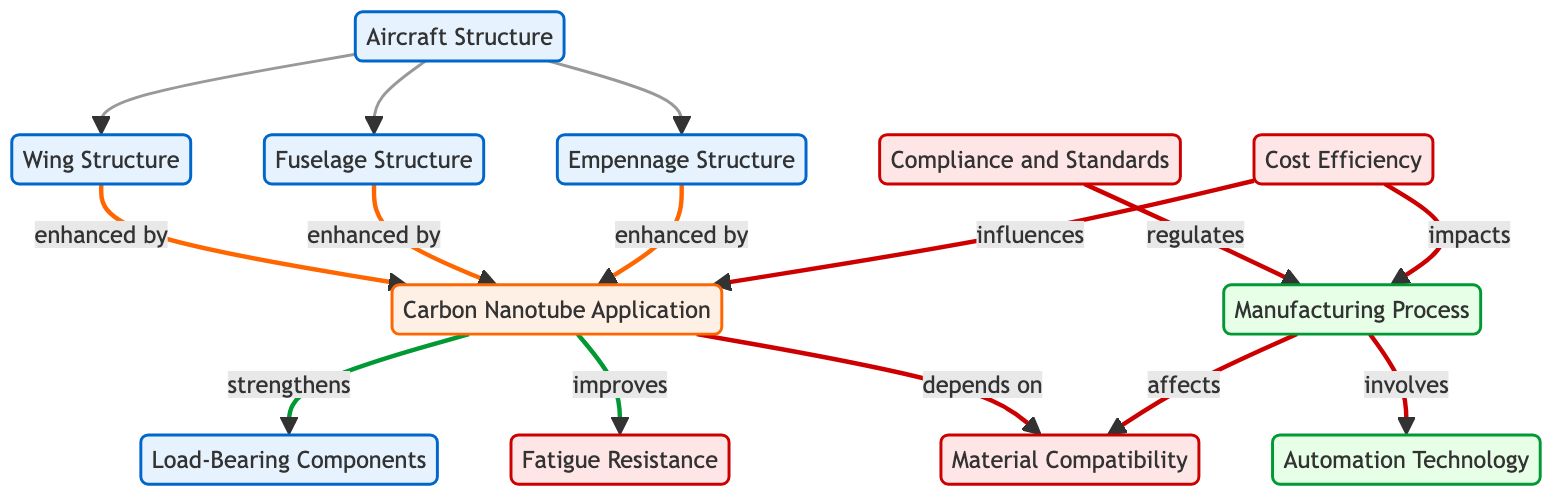What are the three main structures included in Aircraft Structure? The diagram shows that the Aircraft Structure includes Wing Structure, Fuselage Structure, and Empennage Structure, as indicated by the arrows labeled "includes."
Answer: Wing Structure, Fuselage Structure, Empennage Structure How many nodes are representing different components in this diagram? The diagram lists 12 distinct nodes, including the main structures, carbon nanotube application, and various factors or processes related to their integration.
Answer: 12 What relationship exists between the Wing Structure and Carbon Nanotube Application? The arrow labeled "enhanced by" connects the Wing Structure and Carbon Nanotube Application, indicating that the application of carbon nanotubes enhances the wing structure.
Answer: enhanced by Which factor does the Manufacturing Process affect besides Material Compatibility? While Manufacturing Process affects Material Compatibility, it is also indicated to involve Automation Technology, as there’s an arrow labeled "involves" pointing toward Automation Technology.
Answer: Automation Technology What influences the Carbon Nanotube Application? The diagram indicates that Cost Efficiency influences Carbon Nanotube Application, visible through the arrow labeled "influences."
Answer: Cost Efficiency Which components directly depend on Carbon Nanotube Application? Load-Bearing Components and Fatigue Resistance are both directly linked to Carbon Nanotube Application, with arrows indicating that it strengthens and improves these components, respectively.
Answer: Load-Bearing Components, Fatigue Resistance How does Compliance and Standards relate to Manufacturing Process? Compliance and Standards regulate the Manufacturing Process, as represented by the arrow labeled "regulates" connecting the two nodes in the diagram.
Answer: regulates What key relationship defines the impact of Cost Efficiency on Manufacturing Process? The diagram shows that Cost Efficiency impacts the Manufacturing Process, with an arrow labeled "impacts" indicating a direct influence.
Answer: impacts How many edges are connecting the nodes in the diagram? The diagram displays a total of 13 edges, showcasing how different elements are interconnected through various relationships.
Answer: 13 